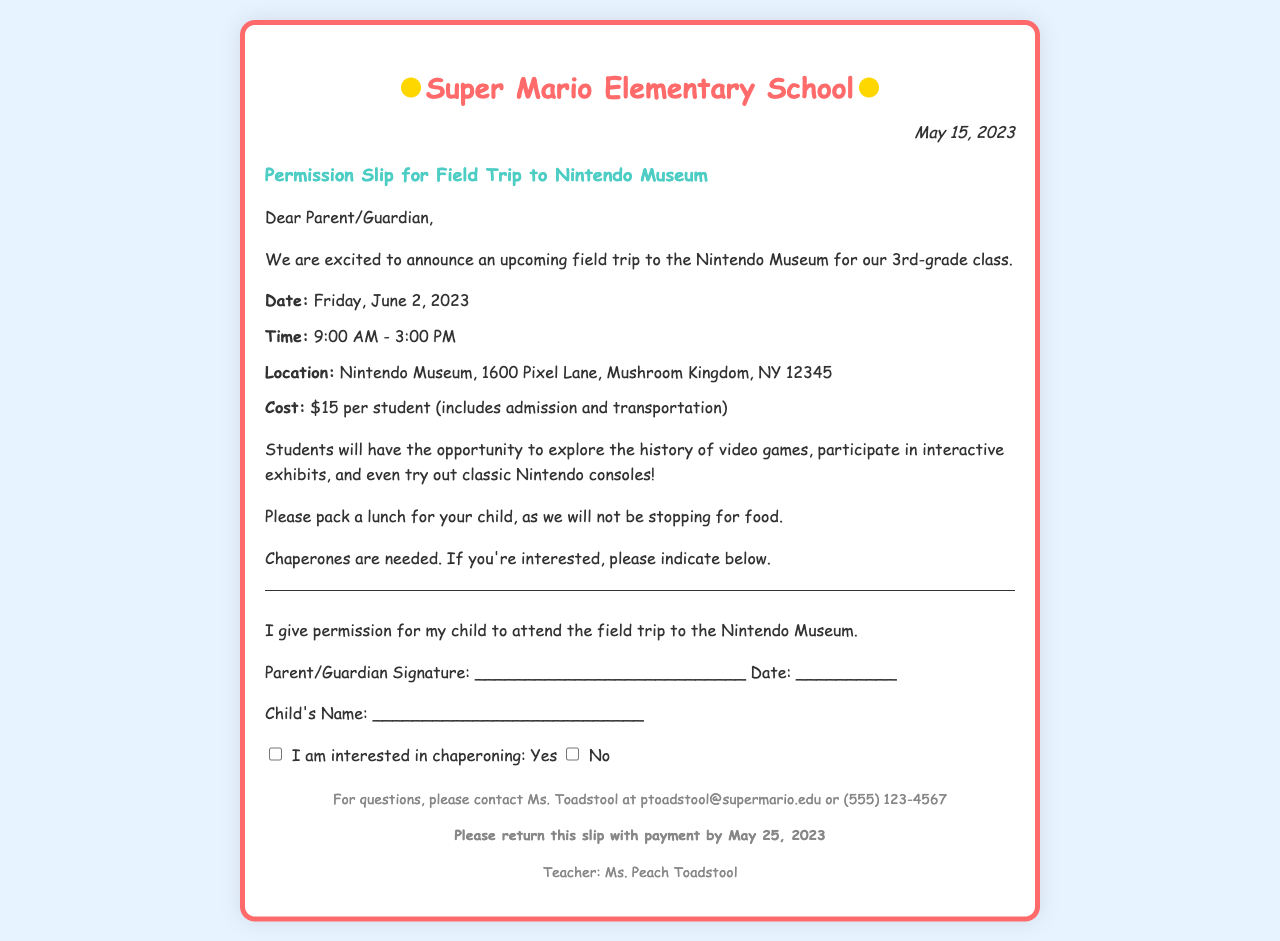what is the date of the field trip? The date of the field trip is mentioned in the document as June 2, 2023.
Answer: June 2, 2023 what is the cost per student? The cost per student is stated in the document as $15.
Answer: $15 who is the teacher organizing the trip? The teacher's name is provided at the bottom of the document as Ms. Peach Toadstool.
Answer: Ms. Peach Toadstool how long will the trip last? The trip's duration is specified as from 9:00 AM to 3:00 PM, which is a total of 6 hours.
Answer: 6 hours what is needed from parents for the trip? The document indicates that chaperones are needed, and parents can indicate their interest below.
Answer: Chaperones what is the deadline to return the permission slip? The deadline to return the slip with payment is mentioned as May 25, 2023.
Answer: May 25, 2023 what should students bring for the trip? The document asks parents to pack a lunch for their child, as no food will be provided.
Answer: Lunch where is the Nintendo Museum located? The location of the Nintendo Museum is detailed in the document as 1600 Pixel Lane, Mushroom Kingdom, NY 12345.
Answer: 1600 Pixel Lane, Mushroom Kingdom, NY 12345 